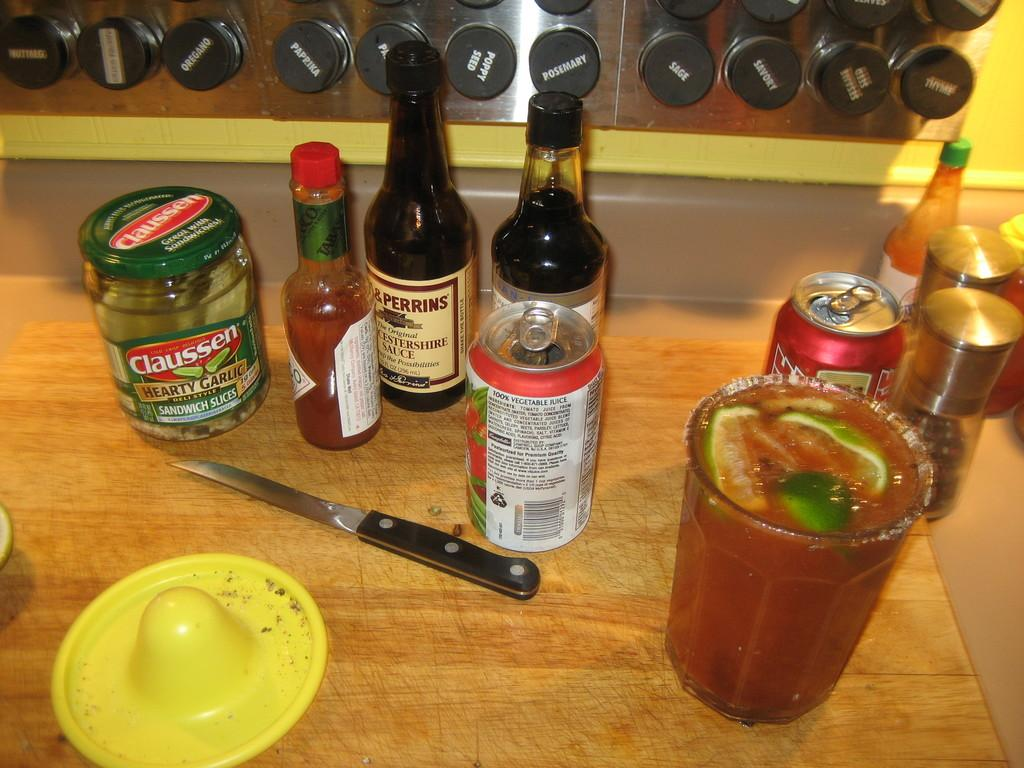Provide a one-sentence caption for the provided image. A table with multiple condiments and drinks, contains a jar of Claussen pickles. 